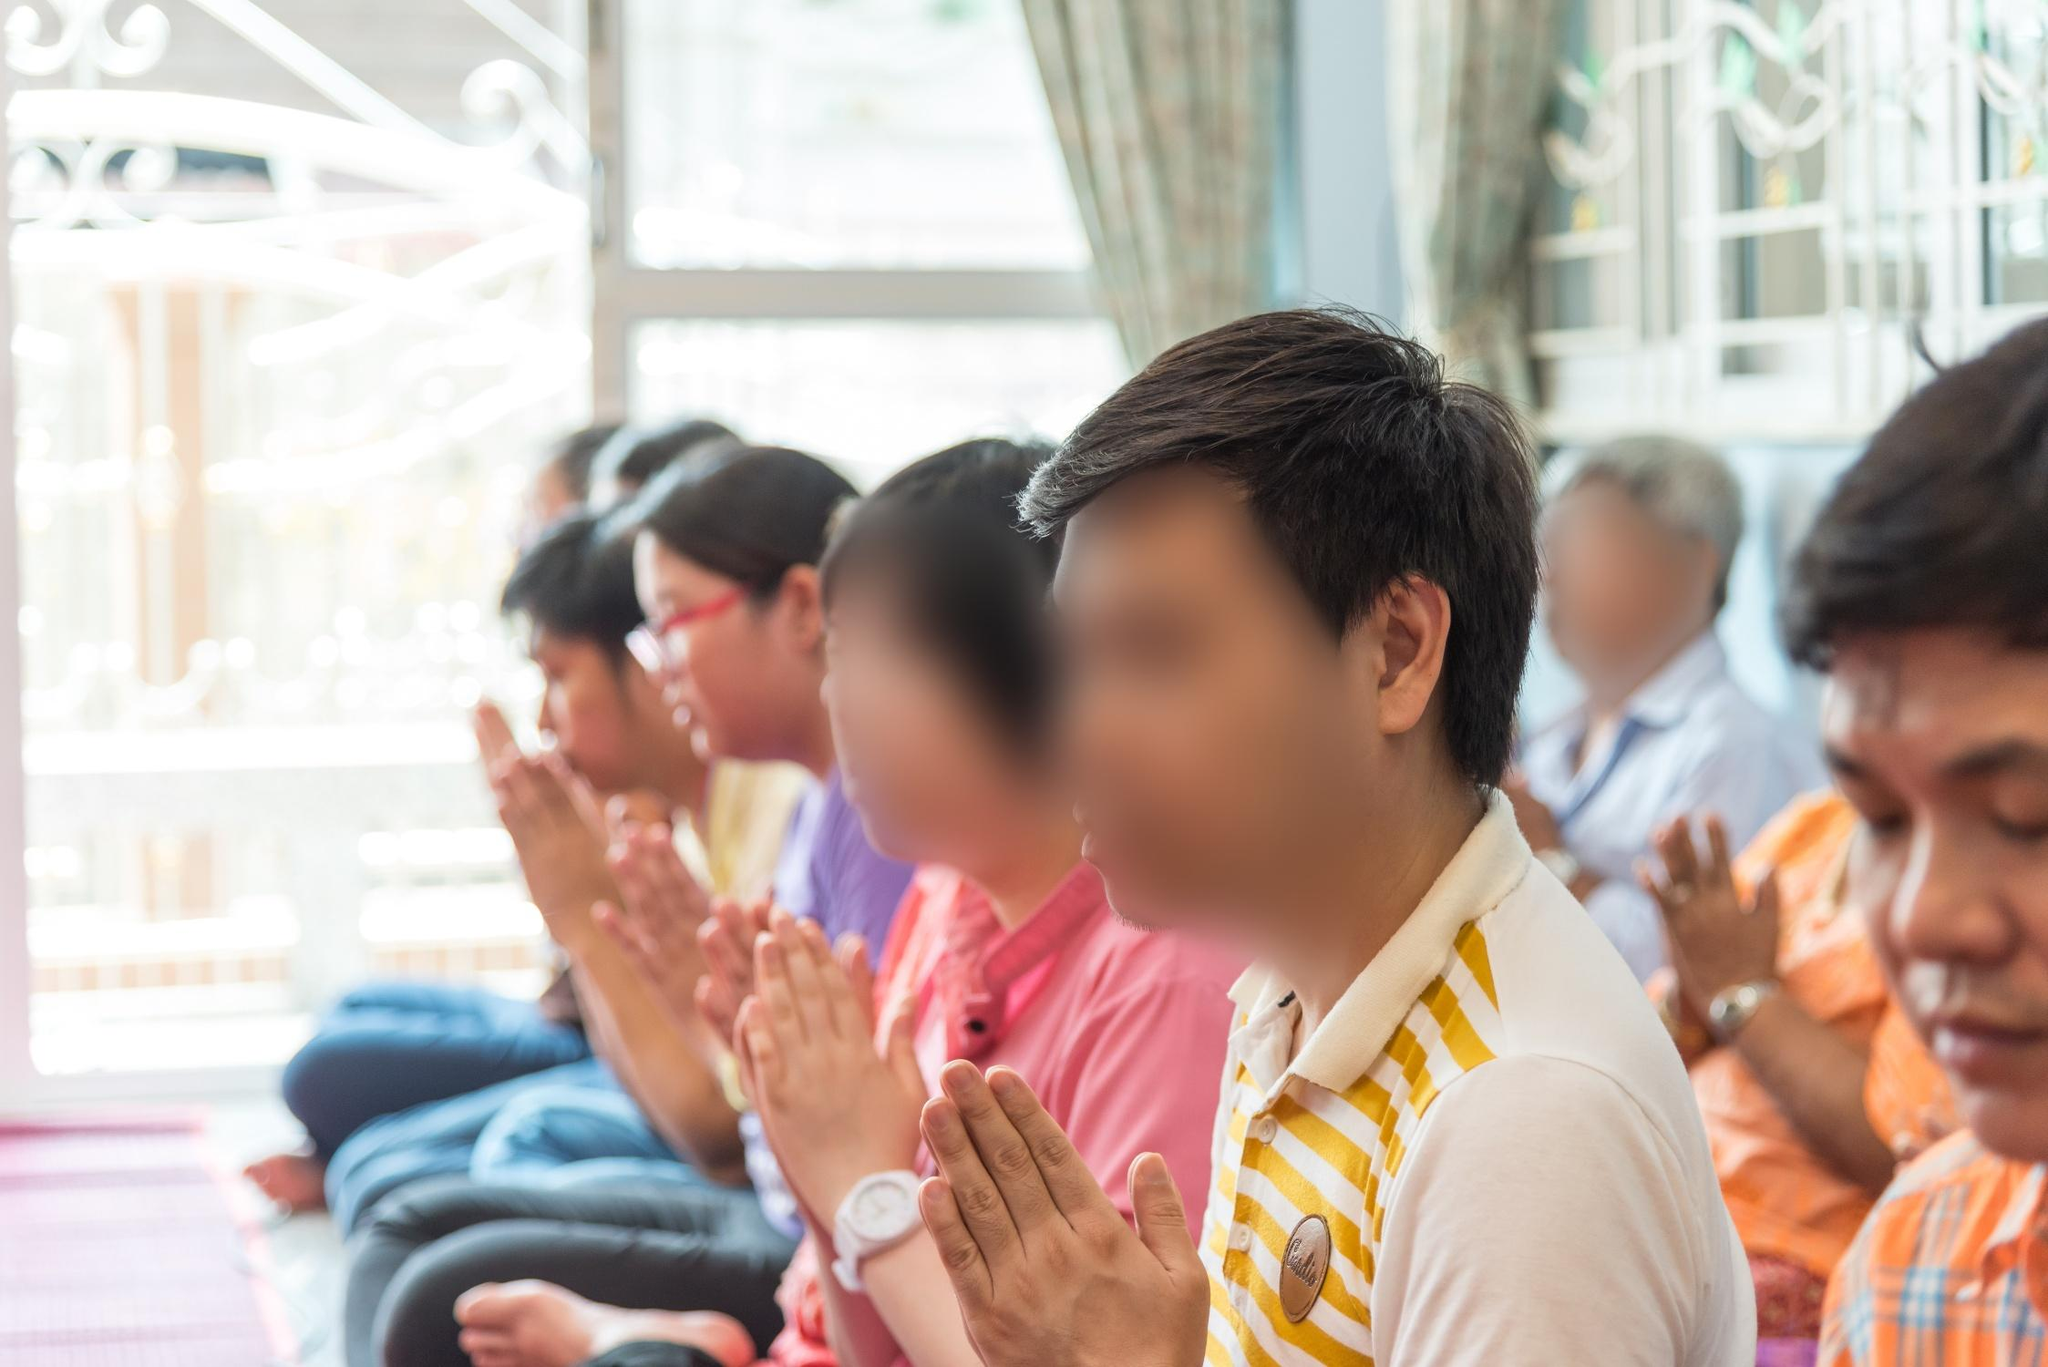What are these people praying for? While the exact focus of their prayers isn't explicit in the image, given the serene and contemplative setting, it is likely that they are engaging in a group prayer session, perhaps offering blessings, asking for peace, or seeking guidance and spiritual enlightenment. Such moments often involve praying for personal and collective well-being, prosperity, and gratitude. Describe the ambience and atmosphere in more detail. The atmosphere in this image exudes quiet reverence and peaceful reflection. The soft natural light filtering through the window creates a gentle, inviting glow that enhances the spiritual ambiance of the temple. The array of colorful clothing worn by the individuals adds a touch of vibrancy, contrasting with the muted tones of the temple's interior. The slight blur in the background suggests a sense of depth and focus on the individuals participating in prayer, evoking a feeling of unity and tranquility. The overall setting seems to be one of calm, introspection, and shared spirituality, fostering a deep sense of connection to one's faith and community. 